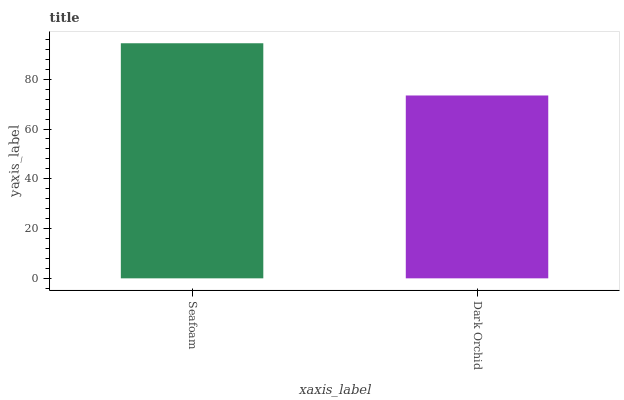Is Dark Orchid the minimum?
Answer yes or no. Yes. Is Seafoam the maximum?
Answer yes or no. Yes. Is Dark Orchid the maximum?
Answer yes or no. No. Is Seafoam greater than Dark Orchid?
Answer yes or no. Yes. Is Dark Orchid less than Seafoam?
Answer yes or no. Yes. Is Dark Orchid greater than Seafoam?
Answer yes or no. No. Is Seafoam less than Dark Orchid?
Answer yes or no. No. Is Seafoam the high median?
Answer yes or no. Yes. Is Dark Orchid the low median?
Answer yes or no. Yes. Is Dark Orchid the high median?
Answer yes or no. No. Is Seafoam the low median?
Answer yes or no. No. 